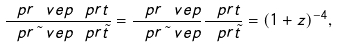<formula> <loc_0><loc_0><loc_500><loc_500>\frac { \ p r \ v e p \ p r t } { \ p r \tilde { \ } v e p \ p r \tilde { t } } = \frac { \ p r \ v e p } { \ p r \tilde { \ } v e p } \frac { \ p r t } { \ p r \tilde { t } } = ( 1 + z ) ^ { - 4 } ,</formula> 